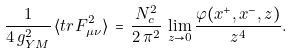Convert formula to latex. <formula><loc_0><loc_0><loc_500><loc_500>\frac { 1 } { 4 \, g _ { Y M } ^ { 2 } } \, \langle t r F _ { \mu \nu } ^ { 2 } \rangle \, = \, \frac { N _ { c } ^ { 2 } } { 2 \, \pi ^ { 2 } } \, \lim _ { z \rightarrow 0 } \frac { \varphi ( x ^ { + } , x ^ { - } , z ) } { z ^ { 4 } } .</formula> 